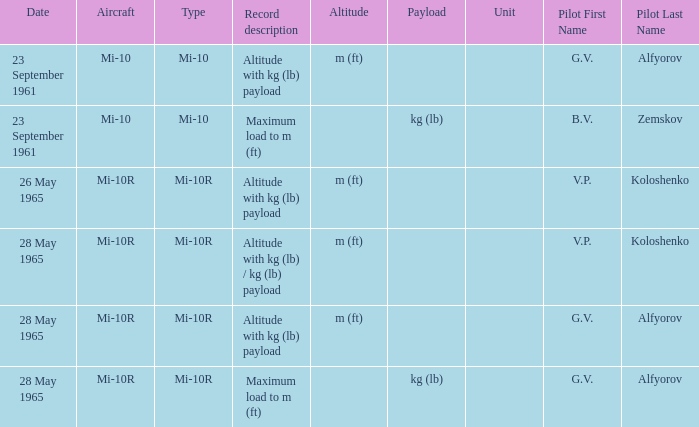Record description of altitude with kg (lb) payload, and a Pilot of g.v. alfyorov had what type? Mi-10, Mi-10R. 